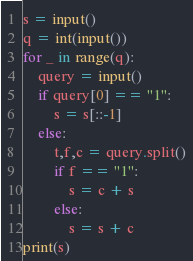<code> <loc_0><loc_0><loc_500><loc_500><_Python_>s = input()
q = int(input())
for _ in range(q):
    query = input()
    if query[0] == "1":
        s = s[::-1]
    else:
        t,f,c = query.split()
        if f == "1":
            s = c + s
        else:
            s = s + c
print(s)</code> 